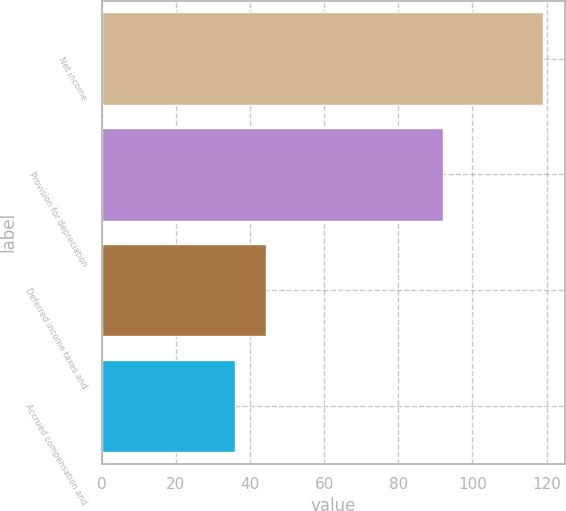<chart> <loc_0><loc_0><loc_500><loc_500><bar_chart><fcel>Net income<fcel>Provision for depreciation<fcel>Deferred income taxes and<fcel>Accrued compensation and<nl><fcel>119<fcel>92<fcel>44.3<fcel>36<nl></chart> 